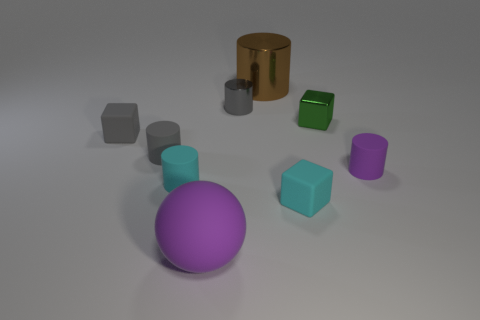Subtract all gray cylinders. How many cylinders are left? 3 Subtract all large brown cylinders. How many cylinders are left? 4 Subtract 1 cylinders. How many cylinders are left? 4 Subtract all red cylinders. Subtract all red spheres. How many cylinders are left? 5 Subtract all cubes. How many objects are left? 6 Subtract all big yellow matte cylinders. Subtract all tiny rubber cubes. How many objects are left? 7 Add 6 small green metallic objects. How many small green metallic objects are left? 7 Add 9 brown shiny cylinders. How many brown shiny cylinders exist? 10 Subtract 0 brown spheres. How many objects are left? 9 